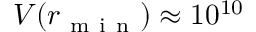<formula> <loc_0><loc_0><loc_500><loc_500>V ( r _ { m i n } ) \approx 1 0 ^ { 1 0 }</formula> 